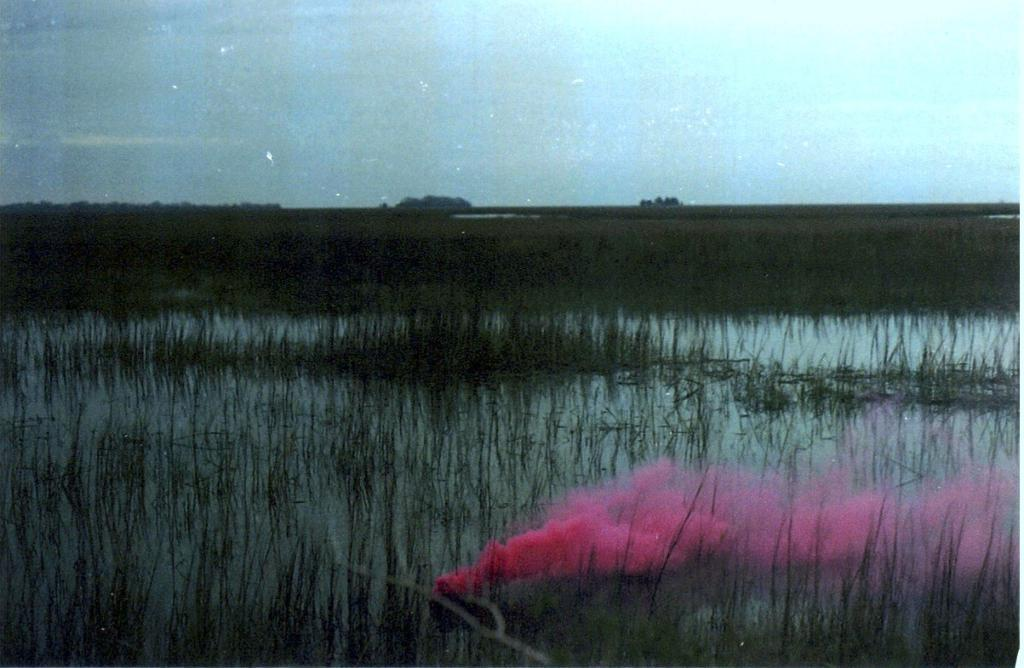What is visible in the foreground of the picture? In the foreground of the picture, there is grass, water, and smoke. What is visible in the background of the picture? In the background of the picture, there is grass, water, and trees. What type of vegetation can be seen in the picture? Grass is visible in both the foreground and background of the picture. What natural elements are present in the picture? Water is present in both the foreground and background of the picture, and trees are visible in the background. Where is the uncle combing his hair in the picture? There is no uncle or combing activity present in the image. What type of water is visible in the picture? The facts provided do not specify the type of water; it is simply water visible in the foreground and background of the picture. 